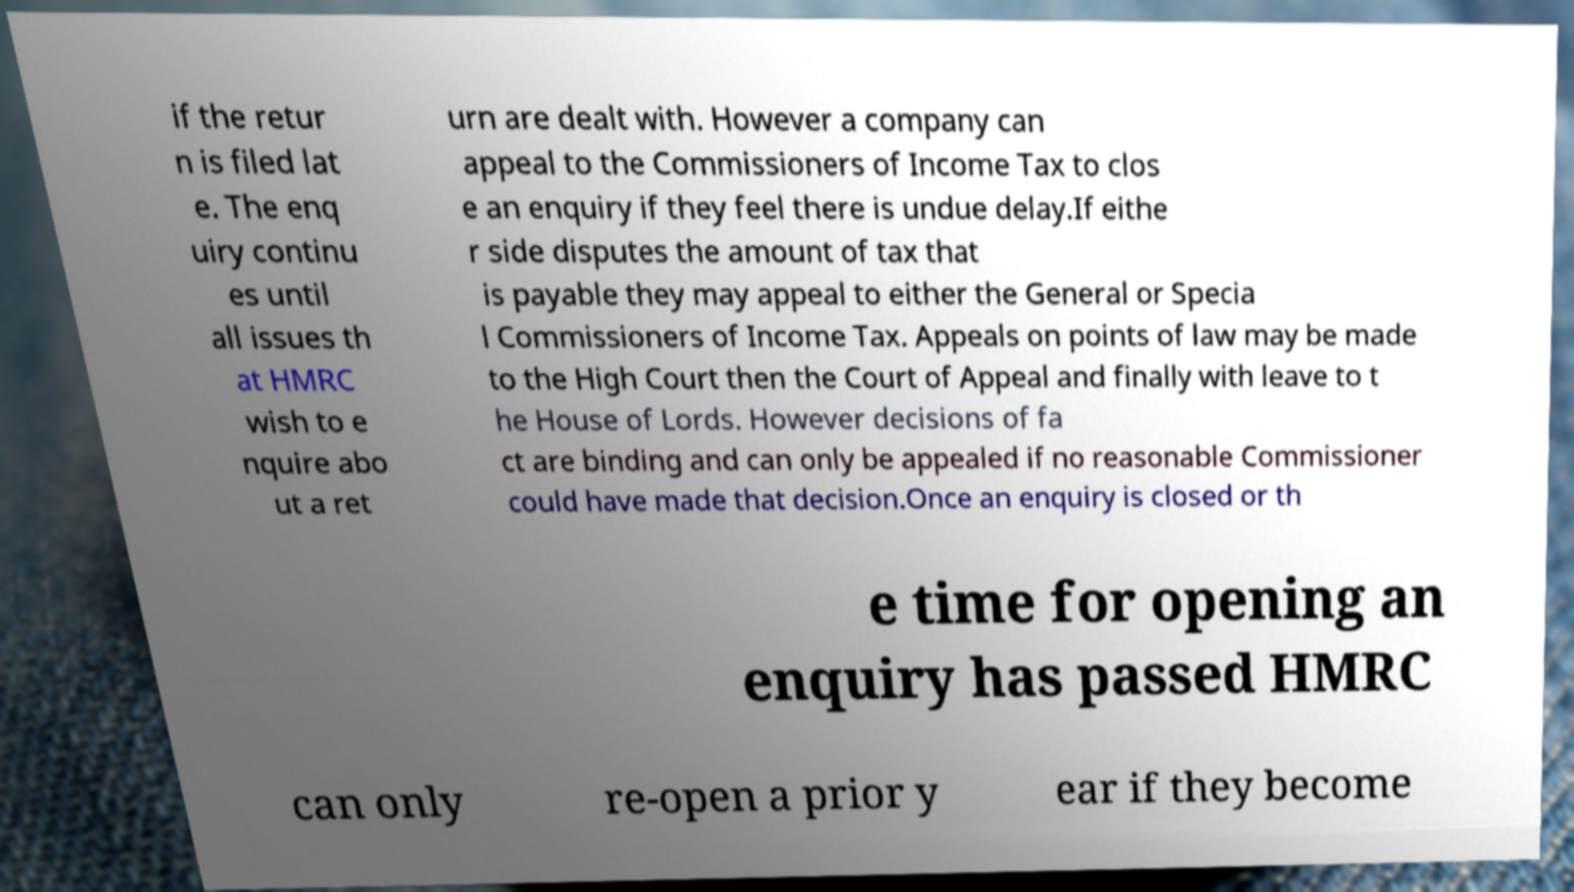For documentation purposes, I need the text within this image transcribed. Could you provide that? if the retur n is filed lat e. The enq uiry continu es until all issues th at HMRC wish to e nquire abo ut a ret urn are dealt with. However a company can appeal to the Commissioners of Income Tax to clos e an enquiry if they feel there is undue delay.If eithe r side disputes the amount of tax that is payable they may appeal to either the General or Specia l Commissioners of Income Tax. Appeals on points of law may be made to the High Court then the Court of Appeal and finally with leave to t he House of Lords. However decisions of fa ct are binding and can only be appealed if no reasonable Commissioner could have made that decision.Once an enquiry is closed or th e time for opening an enquiry has passed HMRC can only re-open a prior y ear if they become 